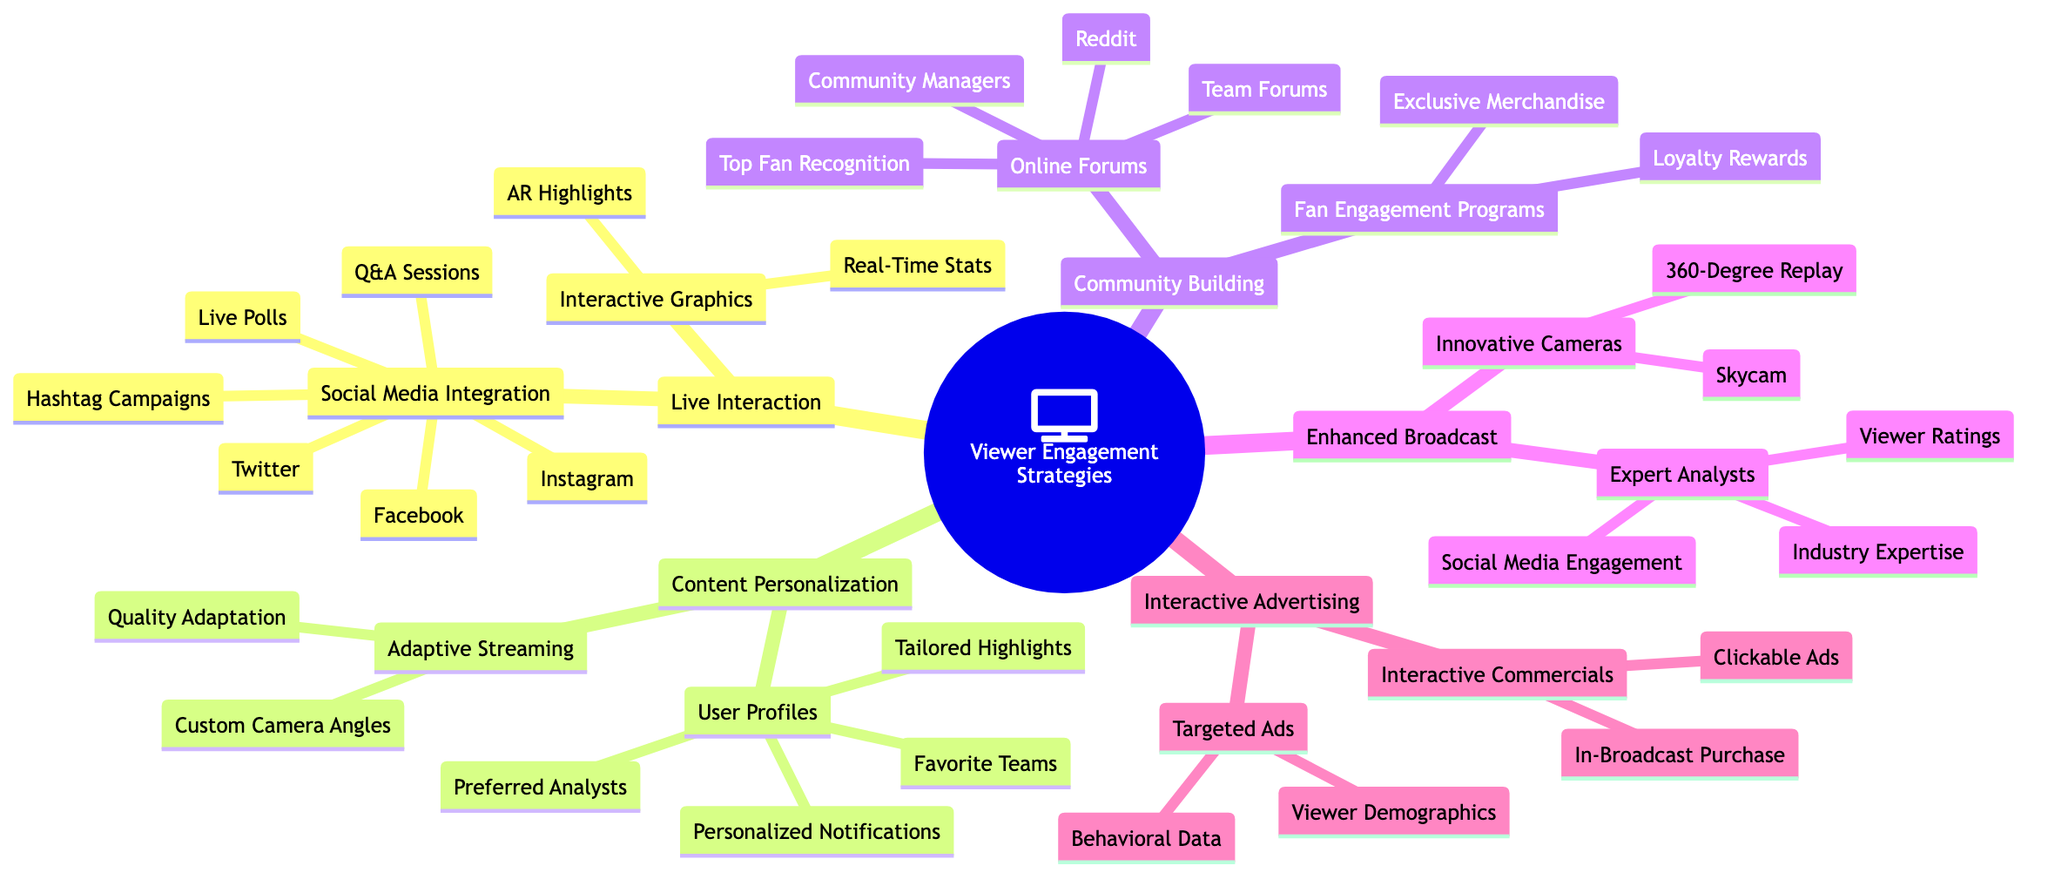What are the platforms included in Social Media Integration? The diagram lists specific platforms under the Social Media Integration node, which are found directly connected to this category. They include Twitter, Facebook, and Instagram.
Answer: Twitter, Facebook, Instagram How many features are listed under Interactive Graphics? By examining the Interactive Graphics node in the diagram, we see it lists two specific features: Real-Time Stats and Augmented Reality Highlights. Thus, there are 2 features.
Answer: 2 What is one strategy included in Community Building? The diagram shows that Community Building has two primary strategies—Fan Engagement Programs and Online Forums. Therefore, one possible answer could be either, as they are both connected directly to the main category.
Answer: Fan Engagement Programs Which type of interactive advertising utilizes viewer demographics? When looking at the Interactive Advertising section of the diagram, the branch Targeted Ads is specifically mentioned as utilizing viewer demographics to deliver targeted advertisements.
Answer: Targeted Ads List one feature of Adaptive Streaming. Within the Adaptive Streaming node, the diagram identifies two specific features: Quality Adaptation and Custom Camera Angles. Therefore, listing either of these features would satisfy the question.
Answer: Quality Adaptation How many nodes are under the Enhanced Broadcast Experience? The Enhanced Broadcast Experience category contains two distinct nodes: Expert Analysts and Innovative Camera Techniques. Therefore, the total count of nodes under this category is 2.
Answer: 2 What are the two elements that comprise Fan Engagement Programs? For the Fan Engagement Programs node, the diagram clearly delineates two components which are Loyalty Rewards and Exclusive Merchandise.
Answer: Loyalty Rewards, Exclusive Merchandise Which segment of the diagram focuses on real-time viewer interaction? The Live Interaction segment explicitly references components that allow for real-time viewer interaction, such as Social Media Integration and Interactive Graphics.
Answer: Live Interaction How does Content Personalization enhance viewer experience? Content Personalization enhances viewer experience through several strategies, including User Profiles, which tailor the viewing experience through preferences and recommendations, as well as Adaptive Streaming to adjust quality and camera angles. This requires synthesizing information from both sub-nodes under Content Personalization.
Answer: User Profiles, Adaptive Streaming 